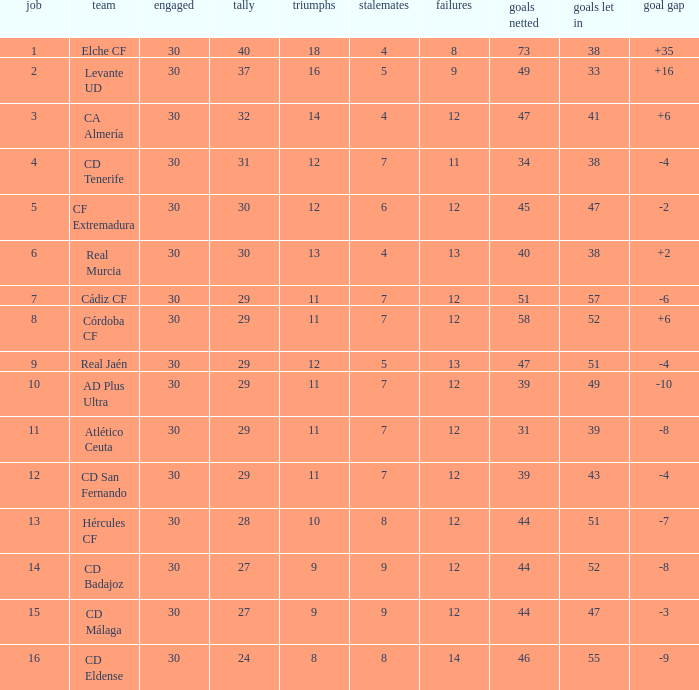What is the average number of goals against with more than 12 wins, 12 losses, and a position greater than 3? None. 